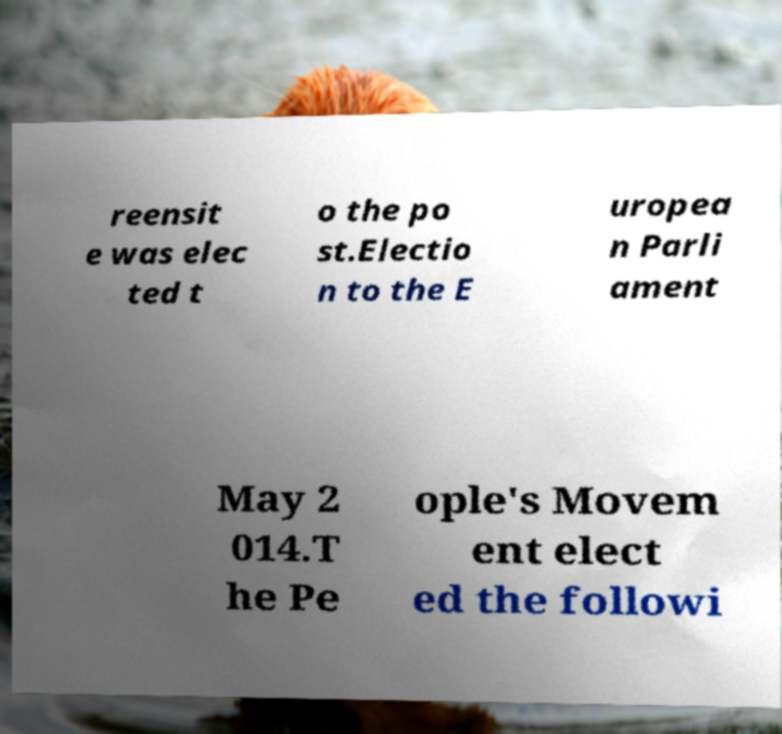Could you assist in decoding the text presented in this image and type it out clearly? reensit e was elec ted t o the po st.Electio n to the E uropea n Parli ament May 2 014.T he Pe ople's Movem ent elect ed the followi 